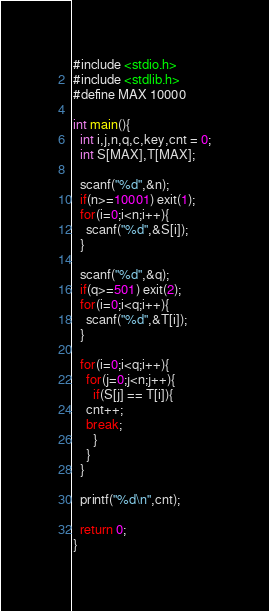Convert code to text. <code><loc_0><loc_0><loc_500><loc_500><_C_>#include <stdio.h>
#include <stdlib.h>
#define MAX 10000

int main(){
  int i,j,n,q,c,key,cnt = 0;
  int S[MAX],T[MAX];
  
  scanf("%d",&n);
  if(n>=10001) exit(1);
  for(i=0;i<n;i++){
    scanf("%d",&S[i]);
  }
  
  scanf("%d",&q);
  if(q>=501) exit(2);
  for(i=0;i<q;i++){
    scanf("%d",&T[i]);
  }

  for(i=0;i<q;i++){
    for(j=0;j<n;j++){
      if(S[j] == T[i]){
	cnt++;
	break;
      }
    }
  }

  printf("%d\n",cnt);
  
  return 0;
}

</code> 